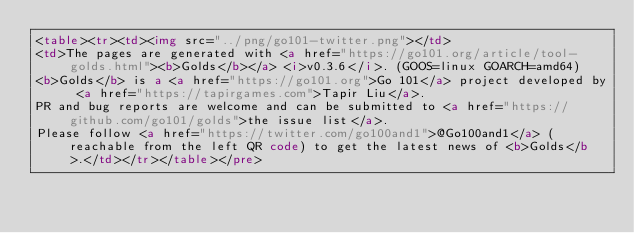Convert code to text. <code><loc_0><loc_0><loc_500><loc_500><_HTML_><table><tr><td><img src="../png/go101-twitter.png"></td>
<td>The pages are generated with <a href="https://go101.org/article/tool-golds.html"><b>Golds</b></a> <i>v0.3.6</i>. (GOOS=linux GOARCH=amd64)
<b>Golds</b> is a <a href="https://go101.org">Go 101</a> project developed by <a href="https://tapirgames.com">Tapir Liu</a>.
PR and bug reports are welcome and can be submitted to <a href="https://github.com/go101/golds">the issue list</a>.
Please follow <a href="https://twitter.com/go100and1">@Go100and1</a> (reachable from the left QR code) to get the latest news of <b>Golds</b>.</td></tr></table></pre></code> 